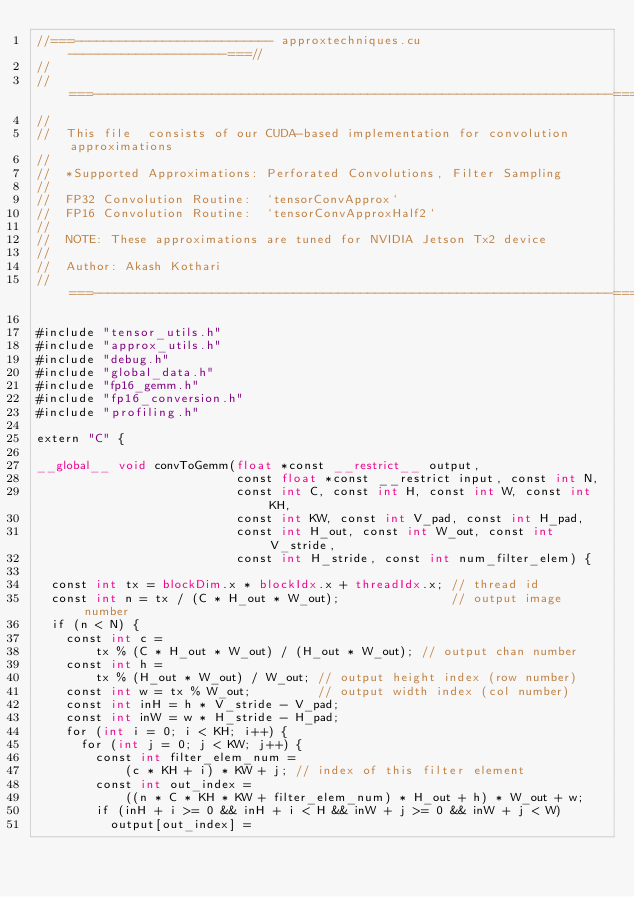Convert code to text. <code><loc_0><loc_0><loc_500><loc_500><_Cuda_>//===--------------------------- approxtechniques.cu ---------------------===//
//
//===----------------------------------------------------------------------===//
//
//  This file  consists of our CUDA-based implementation for convolution approximations
//
//  *Supported Approximations: Perforated Convolutions, Filter Sampling
//
//  FP32 Convolution Routine:  `tensorConvApprox`
//  FP16 Convolution Routine:  `tensorConvApproxHalf2`
// 
//  NOTE: These approximations are tuned for NVIDIA Jetson Tx2 device
//
//  Author: Akash Kothari
//===----------------------------------------------------------------------===//

#include "tensor_utils.h"
#include "approx_utils.h"
#include "debug.h"
#include "global_data.h"
#include "fp16_gemm.h"
#include "fp16_conversion.h"
#include "profiling.h"

extern "C" {

__global__ void convToGemm(float *const __restrict__ output,
                           const float *const __restrict input, const int N,
                           const int C, const int H, const int W, const int KH,
                           const int KW, const int V_pad, const int H_pad,
                           const int H_out, const int W_out, const int V_stride,
                           const int H_stride, const int num_filter_elem) {

  const int tx = blockDim.x * blockIdx.x + threadIdx.x; // thread id
  const int n = tx / (C * H_out * W_out);               // output image number
  if (n < N) {
    const int c =
        tx % (C * H_out * W_out) / (H_out * W_out); // output chan number
    const int h =
        tx % (H_out * W_out) / W_out; // output height index (row number)
    const int w = tx % W_out;         // output width index (col number)
    const int inH = h * V_stride - V_pad;
    const int inW = w * H_stride - H_pad;
    for (int i = 0; i < KH; i++) {
      for (int j = 0; j < KW; j++) {
        const int filter_elem_num =
            (c * KH + i) * KW + j; // index of this filter element
        const int out_index =
            ((n * C * KH * KW + filter_elem_num) * H_out + h) * W_out + w;
        if (inH + i >= 0 && inH + i < H && inW + j >= 0 && inW + j < W)
          output[out_index] =</code> 